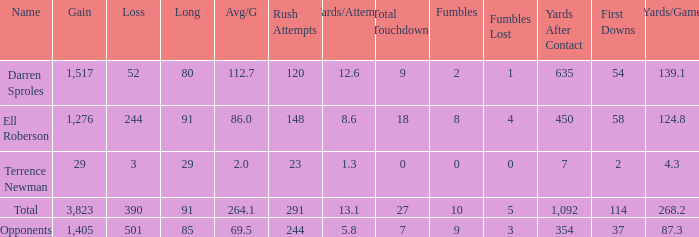When the participant achieved less than 1,405 yards and dropped over 390 yards, what is the aggregate of the lengthy yards? None. 